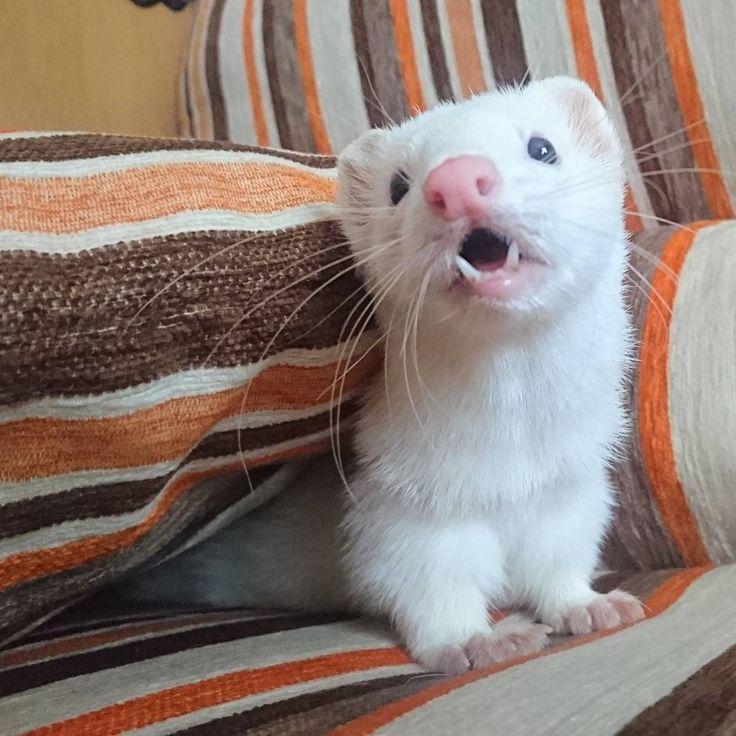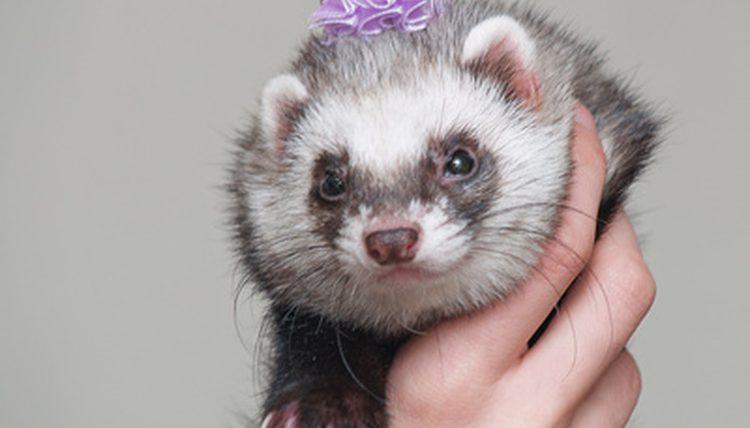The first image is the image on the left, the second image is the image on the right. Evaluate the accuracy of this statement regarding the images: "The right image features a human hand holding a ferret.". Is it true? Answer yes or no. Yes. 